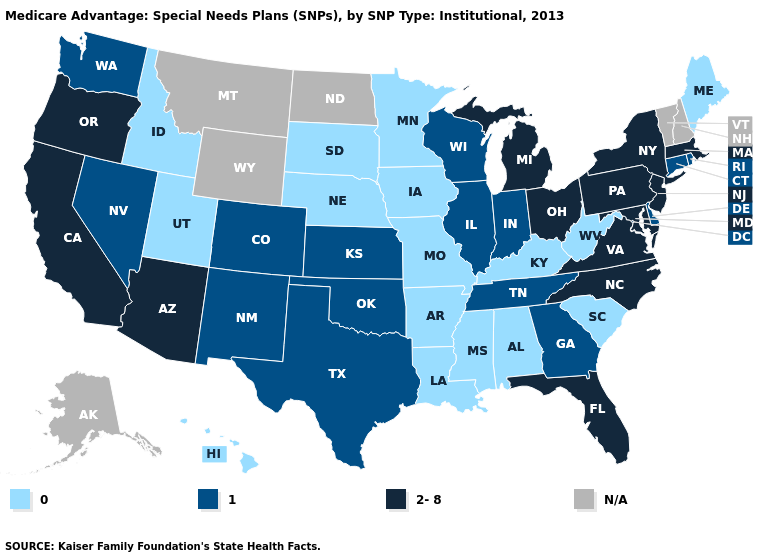What is the value of South Carolina?
Answer briefly. 0. How many symbols are there in the legend?
Keep it brief. 4. Does the map have missing data?
Short answer required. Yes. What is the lowest value in the South?
Short answer required. 0. What is the value of Connecticut?
Keep it brief. 1. Which states have the lowest value in the MidWest?
Quick response, please. Iowa, Minnesota, Missouri, Nebraska, South Dakota. Which states have the lowest value in the USA?
Keep it brief. Alabama, Arkansas, Hawaii, Iowa, Idaho, Kentucky, Louisiana, Maine, Minnesota, Missouri, Mississippi, Nebraska, South Carolina, South Dakota, Utah, West Virginia. Does the first symbol in the legend represent the smallest category?
Keep it brief. Yes. Does Hawaii have the highest value in the USA?
Concise answer only. No. What is the value of Vermont?
Be succinct. N/A. Among the states that border North Dakota , which have the lowest value?
Write a very short answer. Minnesota, South Dakota. What is the value of South Dakota?
Give a very brief answer. 0. Is the legend a continuous bar?
Concise answer only. No. 